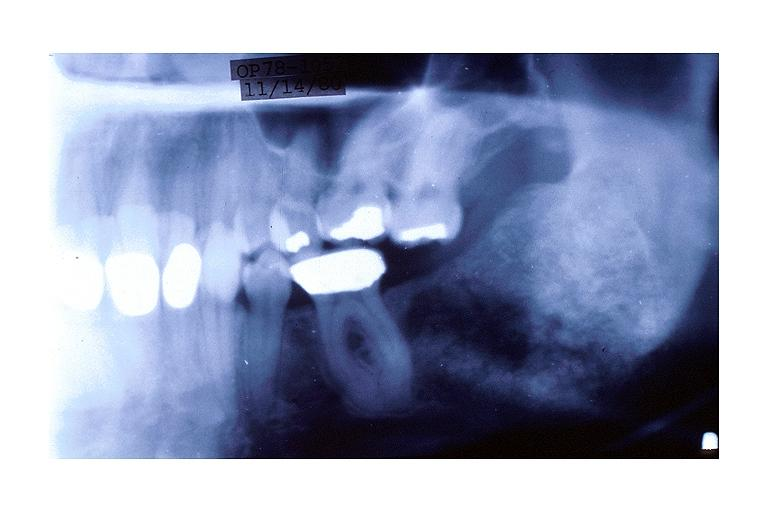s serous cyst present?
Answer the question using a single word or phrase. No 